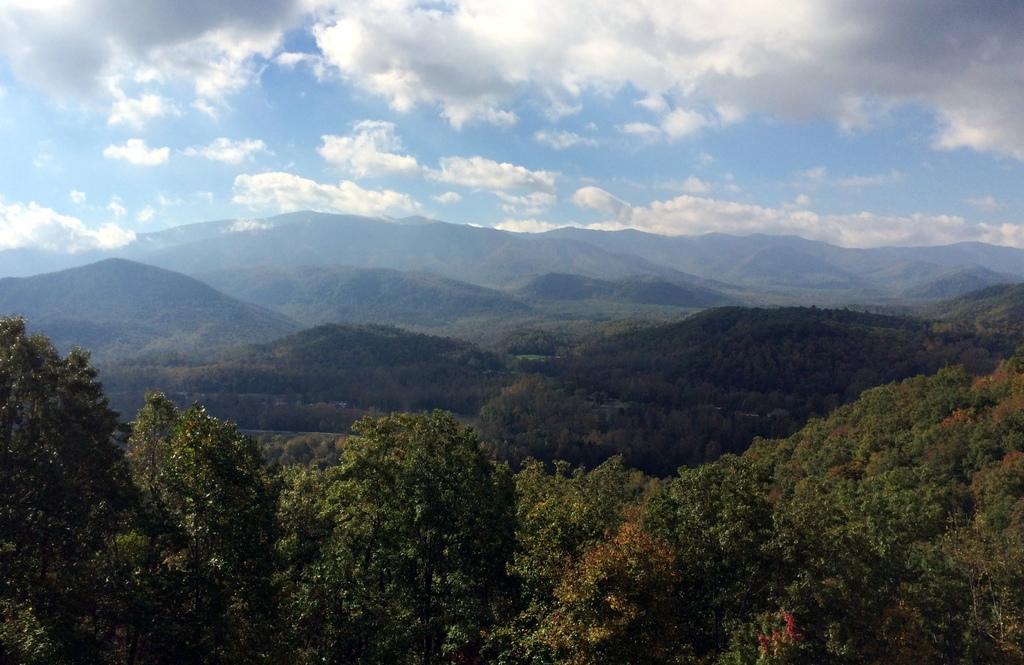What type of natural features can be seen in the image? There are trees and hills in the image. What is visible in the background of the image? The sky is visible in the image. What can be observed in the sky? Clouds are present in the sky. How many jellyfish can be seen swimming in the image? There are no jellyfish present in the image; it features trees, hills, and a sky with clouds. 